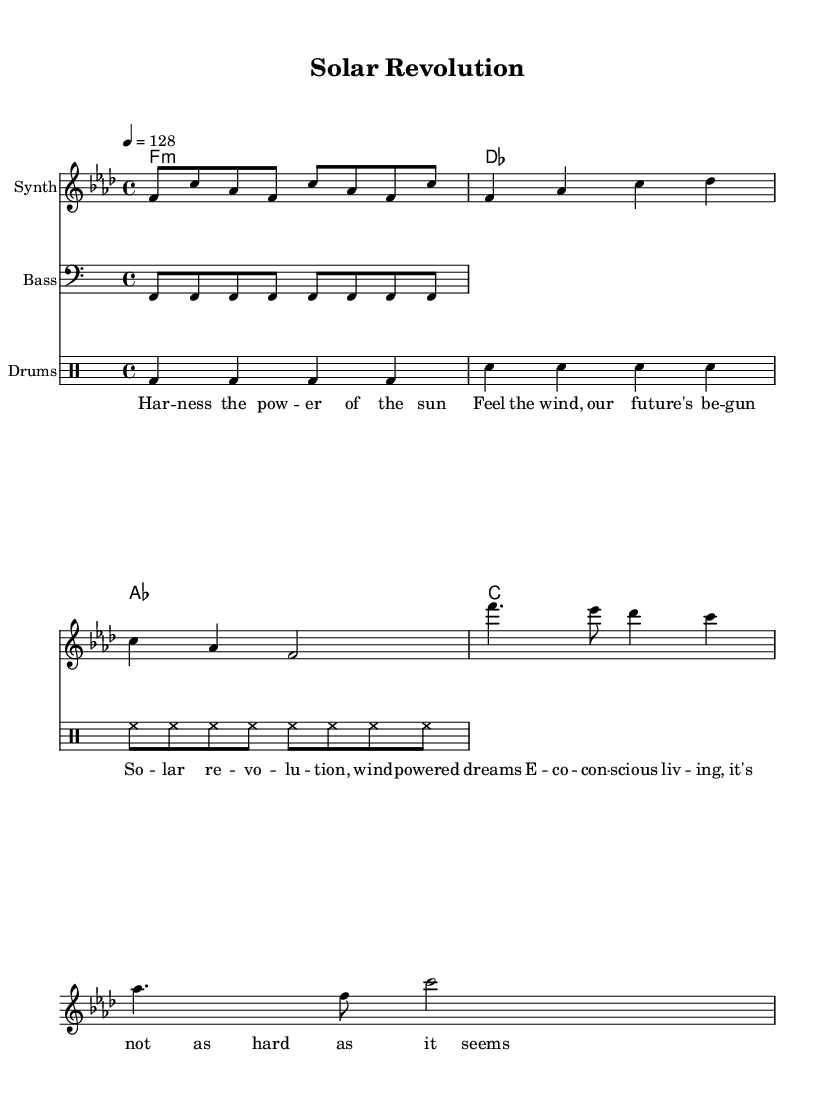What is the key signature of this music? The key signature is F minor, which has four flats (B♭, E♭, A♭, D♭). This can be determined by examining the global section where the key is stated.
Answer: F minor What is the time signature of this music? The time signature is four-four, indicated by the notation at the beginning of the score. It is noted as "4/4" in the global section.
Answer: 4/4 What is the tempo marking of this music? The tempo marking is 128 beats per minute, which is specified in the global section of the score. It means the quarter note gets one beat at this tempo.
Answer: 128 How many measures are in the verse section? The verse section consists of two measures, which can be seen in the melody line where specific note groupings for the verse begin and end.
Answer: 2 What instruments are used in this score? The score contains four instruments: Synth, Bass, Drums, and a group for Chord Names. This information is seen in the "instrumentName" labels within each respective staff section.
Answer: Synth, Bass, Drums What lyrical theme does this music convey? The lyrics focus on themes of sustainable living and environmental consciousness, clearly illustrated by phrases like "solar revolution" and "eco-conscious living." This is evident from the lyrics provided in the lyrics section.
Answer: Sustainable living What is the main rhythmic feature of the drum part? The main rhythmic feature consists of a consistent four beats for each measure with variations for bass and snare drums, commonly used in dance music for a steady pulse. This can be seen in the "drummode" section of the score.
Answer: Steady pulse 